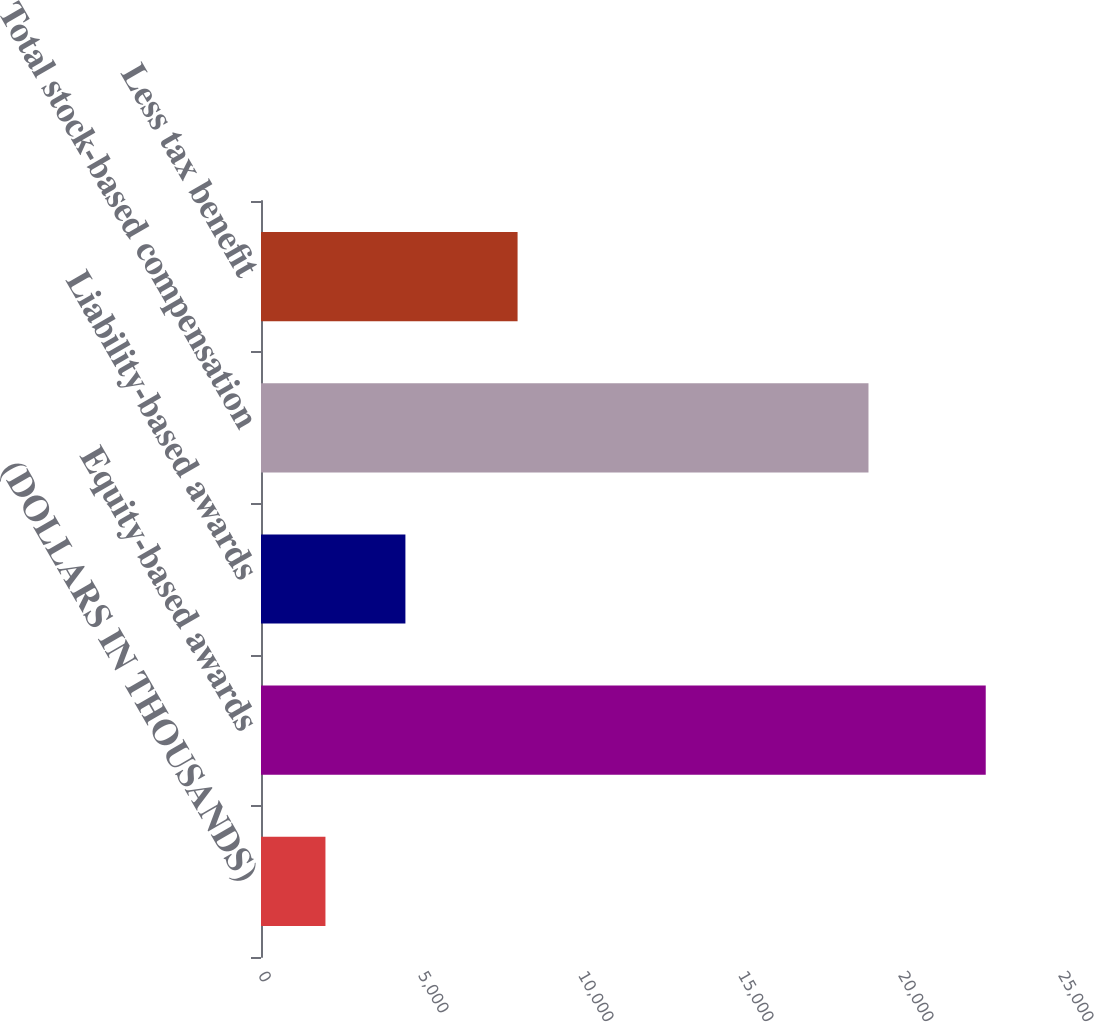Convert chart. <chart><loc_0><loc_0><loc_500><loc_500><bar_chart><fcel>(DOLLARS IN THOUSANDS)<fcel>Equity-based awards<fcel>Liability-based awards<fcel>Total stock-based compensation<fcel>Less tax benefit<nl><fcel>2014<fcel>22648<fcel>4512.8<fcel>18984<fcel>8018<nl></chart> 